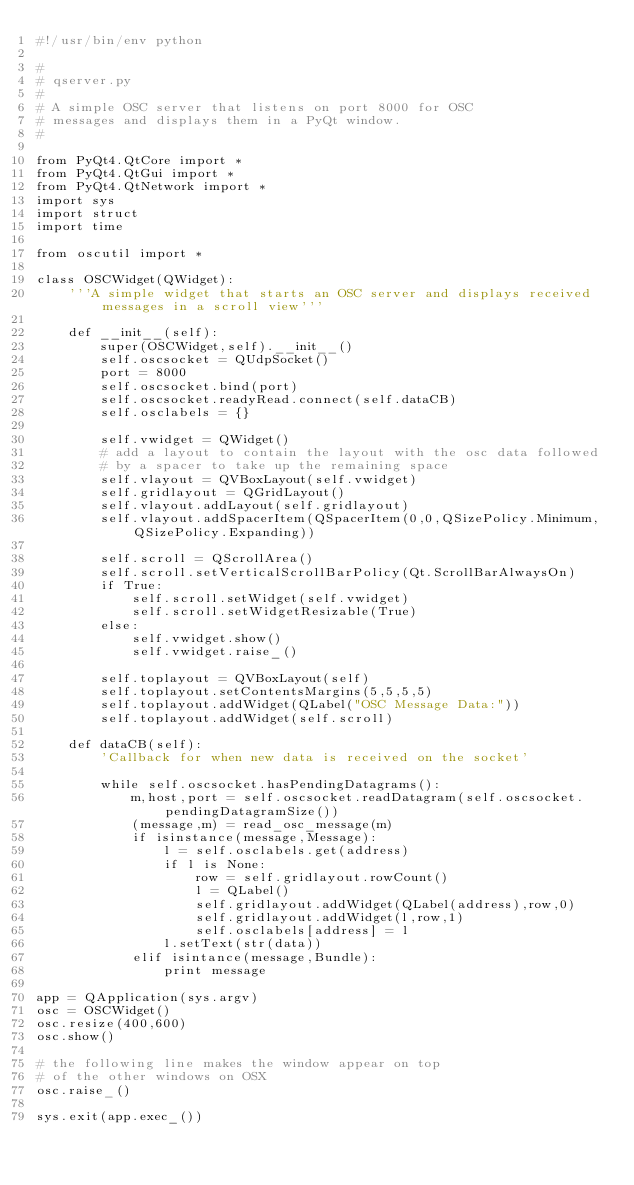<code> <loc_0><loc_0><loc_500><loc_500><_Python_>#!/usr/bin/env python

#
# qserver.py
#
# A simple OSC server that listens on port 8000 for OSC
# messages and displays them in a PyQt window.
#

from PyQt4.QtCore import *
from PyQt4.QtGui import *
from PyQt4.QtNetwork import *
import sys
import struct
import time

from oscutil import *

class OSCWidget(QWidget):
    '''A simple widget that starts an OSC server and displays received messages in a scroll view'''

    def __init__(self):
        super(OSCWidget,self).__init__()
        self.oscsocket = QUdpSocket()
        port = 8000
        self.oscsocket.bind(port)
        self.oscsocket.readyRead.connect(self.dataCB)
        self.osclabels = {}

        self.vwidget = QWidget()
        # add a layout to contain the layout with the osc data followed
        # by a spacer to take up the remaining space
        self.vlayout = QVBoxLayout(self.vwidget) 
        self.gridlayout = QGridLayout()
        self.vlayout.addLayout(self.gridlayout)
        self.vlayout.addSpacerItem(QSpacerItem(0,0,QSizePolicy.Minimum,QSizePolicy.Expanding))

        self.scroll = QScrollArea()
        self.scroll.setVerticalScrollBarPolicy(Qt.ScrollBarAlwaysOn)
        if True:
            self.scroll.setWidget(self.vwidget)
            self.scroll.setWidgetResizable(True)
        else:
            self.vwidget.show()
            self.vwidget.raise_()

        self.toplayout = QVBoxLayout(self)
        self.toplayout.setContentsMargins(5,5,5,5)
        self.toplayout.addWidget(QLabel("OSC Message Data:"))
        self.toplayout.addWidget(self.scroll)

    def dataCB(self):
        'Callback for when new data is received on the socket'

        while self.oscsocket.hasPendingDatagrams():
            m,host,port = self.oscsocket.readDatagram(self.oscsocket.pendingDatagramSize())
            (message,m) = read_osc_message(m)
            if isinstance(message,Message):
                l = self.osclabels.get(address)
                if l is None:
                    row = self.gridlayout.rowCount()
                    l = QLabel()
                    self.gridlayout.addWidget(QLabel(address),row,0)
                    self.gridlayout.addWidget(l,row,1)
                    self.osclabels[address] = l
                l.setText(str(data))
            elif isintance(message,Bundle):
                print message
      
app = QApplication(sys.argv)
osc = OSCWidget()
osc.resize(400,600)
osc.show()

# the following line makes the window appear on top
# of the other windows on OSX
osc.raise_()

sys.exit(app.exec_())
</code> 